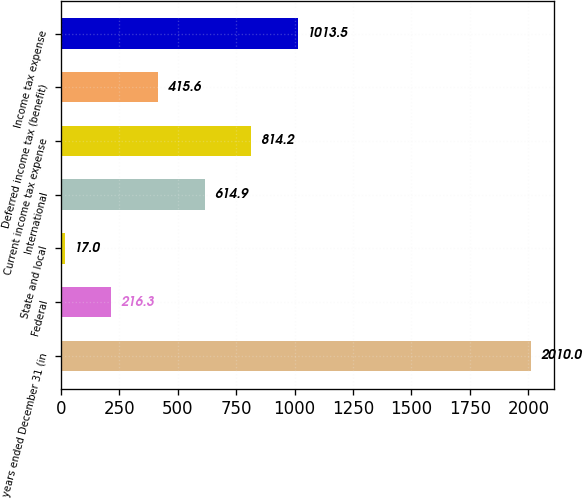Convert chart. <chart><loc_0><loc_0><loc_500><loc_500><bar_chart><fcel>years ended December 31 (in<fcel>Federal<fcel>State and local<fcel>International<fcel>Current income tax expense<fcel>Deferred income tax (benefit)<fcel>Income tax expense<nl><fcel>2010<fcel>216.3<fcel>17<fcel>614.9<fcel>814.2<fcel>415.6<fcel>1013.5<nl></chart> 